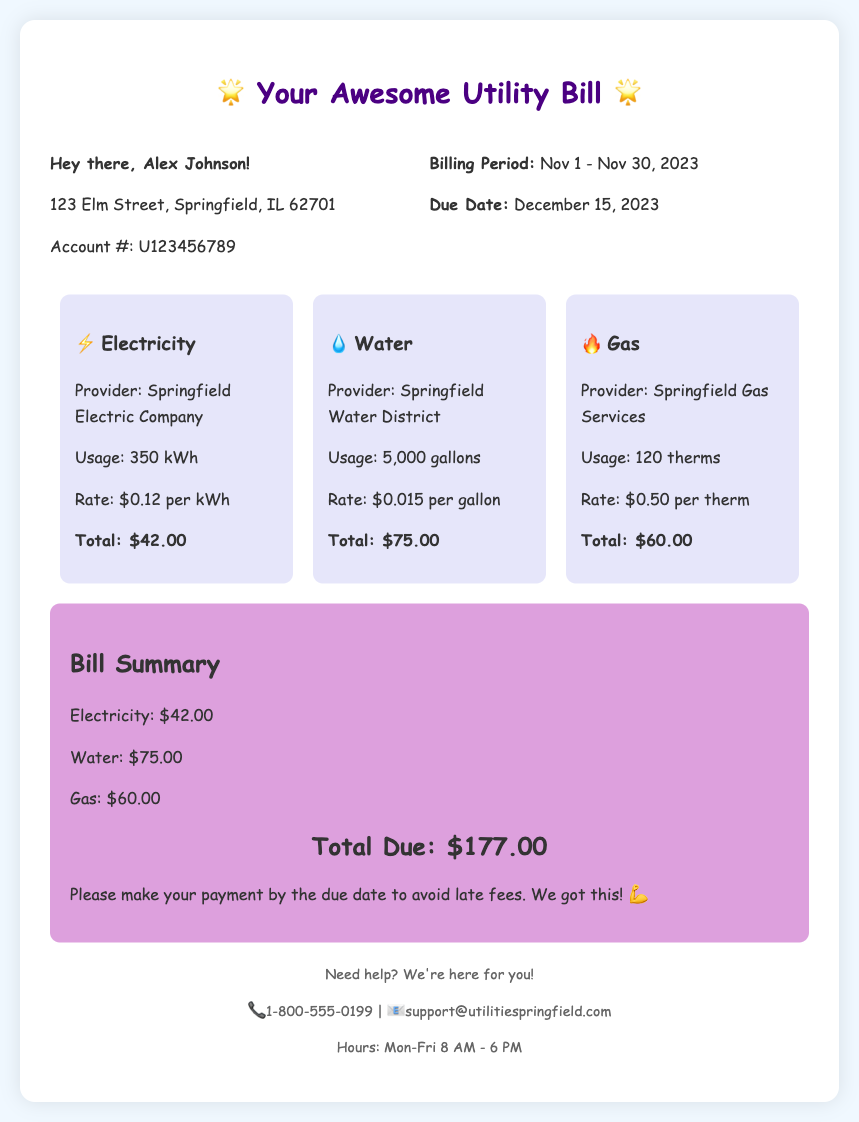What is the total due amount? The total due amount is detailed in the summary section of the bill, which adds up all the charges.
Answer: $177.00 Who is the electricity provider? The provider of electricity is listed under the electricity charges section of the bill.
Answer: Springfield Electric Company What is the water usage amount? The document specifies the amount of water used in gallons under the water charges section.
Answer: 5,000 gallons What is the due date for the bill? The due date is mentioned in the billing information section of the bill.
Answer: December 15, 2023 How many therms were used for gas? The gas usage is specified in the gas charges section of the document.
Answer: 120 therms What is the rate per gallon for water? The rate for water is provided in the water charges section of the bill.
Answer: $0.015 per gallon What will happen if payment is not made by the due date? This information can be inferred from the summary note encouraging timely payment to avoid fees.
Answer: Late fees What is the total electricity charge? The total electricity charge is summarized under the electricity charges section.
Answer: $42.00 What is the billed address? The address detailed for the account holder is in the billing information section of the bill.
Answer: 123 Elm Street, Springfield, IL 62701 